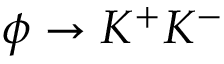<formula> <loc_0><loc_0><loc_500><loc_500>\phi \rightarrow K ^ { + } K ^ { - }</formula> 